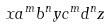<formula> <loc_0><loc_0><loc_500><loc_500>x a ^ { m } b ^ { n } y c ^ { m } d ^ { n } z</formula> 